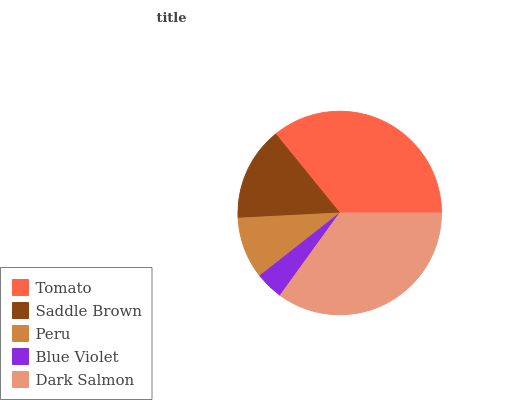Is Blue Violet the minimum?
Answer yes or no. Yes. Is Tomato the maximum?
Answer yes or no. Yes. Is Saddle Brown the minimum?
Answer yes or no. No. Is Saddle Brown the maximum?
Answer yes or no. No. Is Tomato greater than Saddle Brown?
Answer yes or no. Yes. Is Saddle Brown less than Tomato?
Answer yes or no. Yes. Is Saddle Brown greater than Tomato?
Answer yes or no. No. Is Tomato less than Saddle Brown?
Answer yes or no. No. Is Saddle Brown the high median?
Answer yes or no. Yes. Is Saddle Brown the low median?
Answer yes or no. Yes. Is Blue Violet the high median?
Answer yes or no. No. Is Dark Salmon the low median?
Answer yes or no. No. 